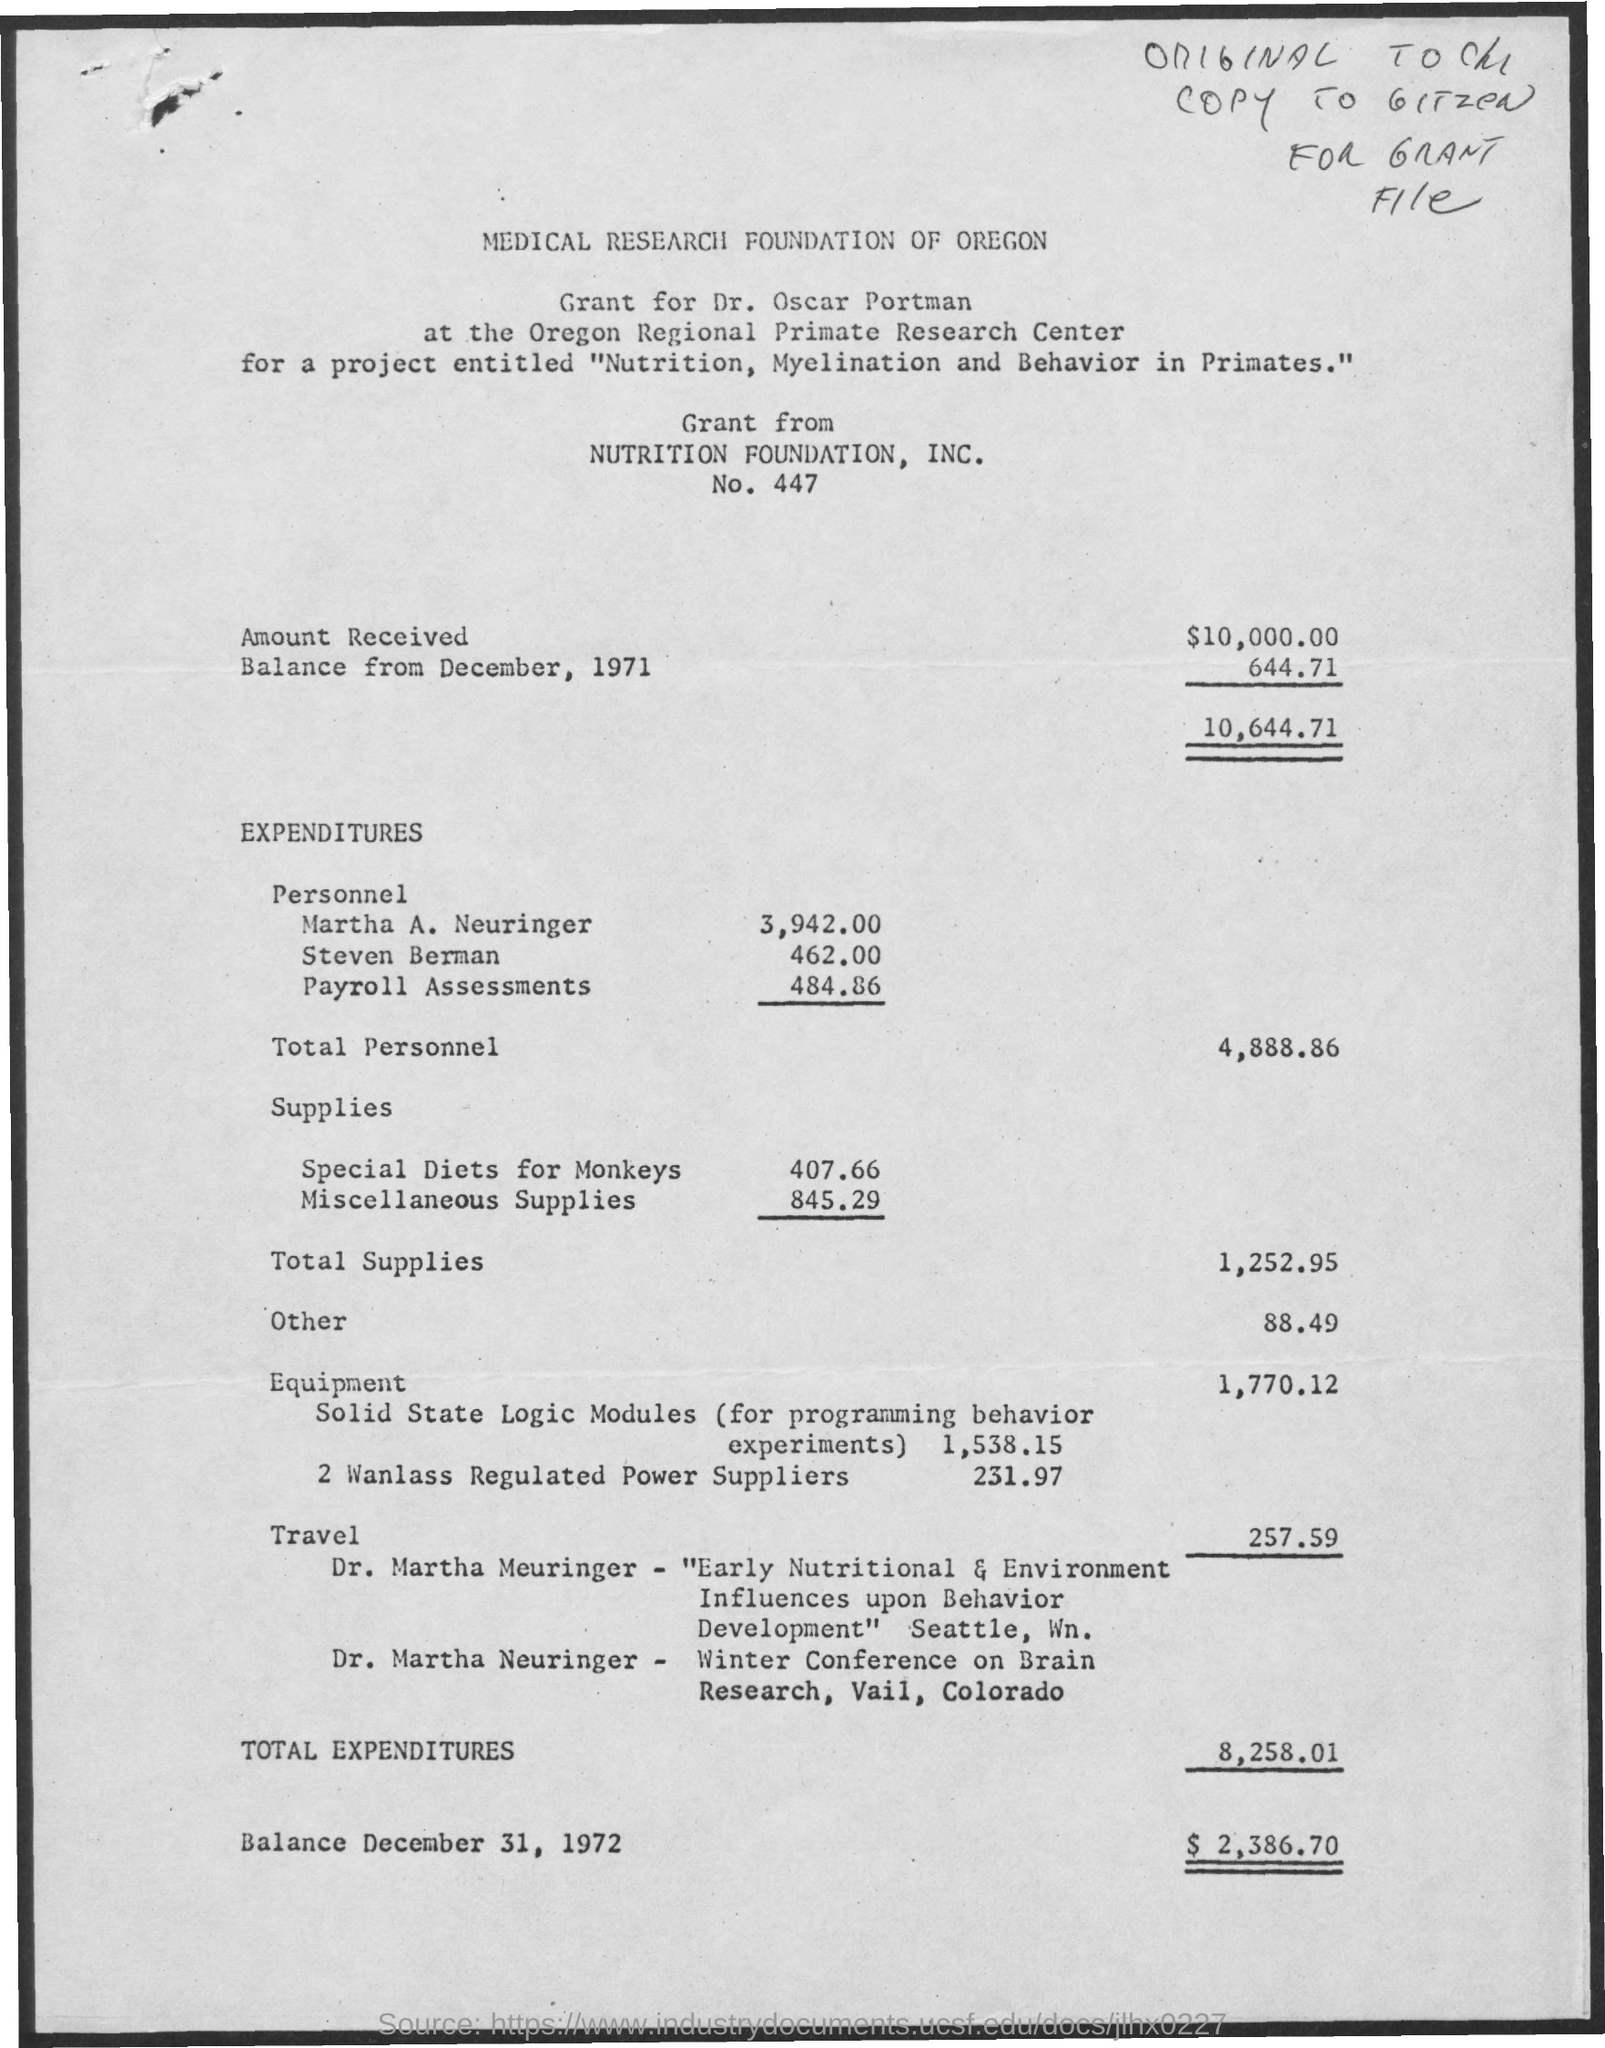Which institution is mentioned at the top of the page?
Offer a very short reply. MEDICAL RESEARCH FOUNDATION OF OREGON. Who has been awarded the grant?
Make the answer very short. Dr. Oscar Portman. For which project has the grant been awarded?
Offer a terse response. Nutrition, Myelination and Behavior in Primates. From whom is the grant?
Ensure brevity in your answer.  NUTRITION FOUNDATION, INC. 